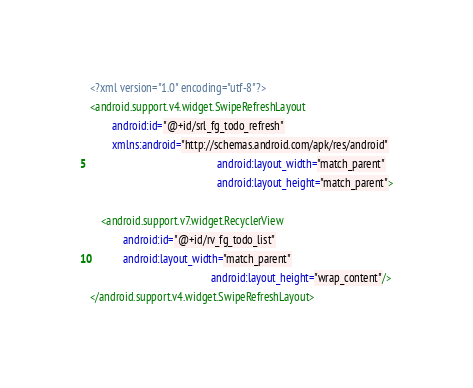Convert code to text. <code><loc_0><loc_0><loc_500><loc_500><_XML_><?xml version="1.0" encoding="utf-8"?>
<android.support.v4.widget.SwipeRefreshLayout
        android:id="@+id/srl_fg_todo_refresh"
        xmlns:android="http://schemas.android.com/apk/res/android"
                                              android:layout_width="match_parent"
                                              android:layout_height="match_parent">

    <android.support.v7.widget.RecyclerView
            android:id="@+id/rv_fg_todo_list"
            android:layout_width="match_parent"
                                            android:layout_height="wrap_content"/>
</android.support.v4.widget.SwipeRefreshLayout></code> 